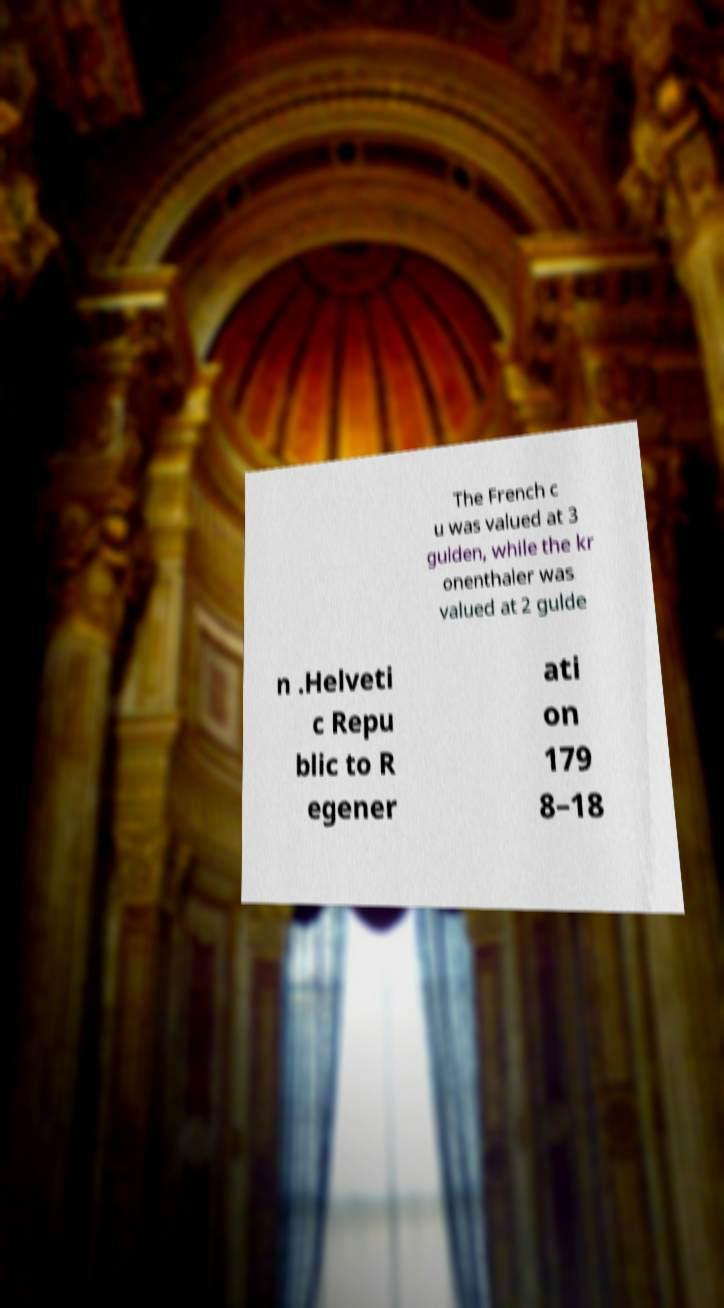For documentation purposes, I need the text within this image transcribed. Could you provide that? The French c u was valued at 3 gulden, while the kr onenthaler was valued at 2 gulde n .Helveti c Repu blic to R egener ati on 179 8–18 